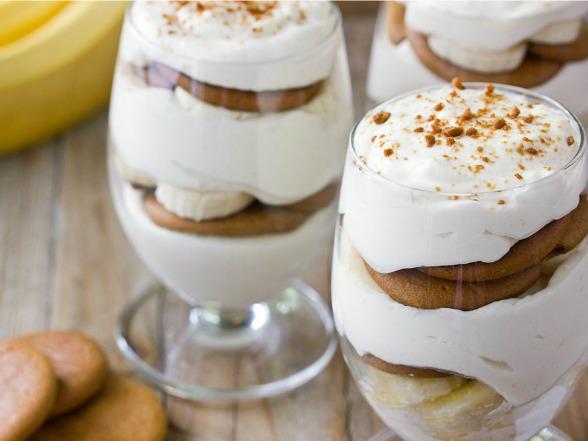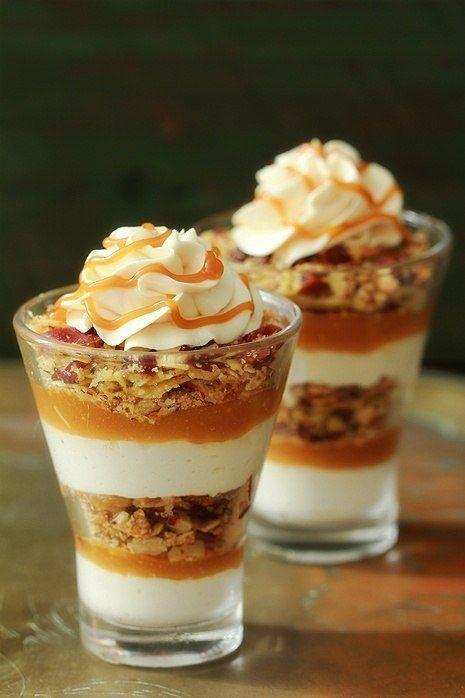The first image is the image on the left, the second image is the image on the right. Evaluate the accuracy of this statement regarding the images: "In at least one image, an untouched dessert is served in a large bowl, rather than individual serving dishes.". Is it true? Answer yes or no. No. 